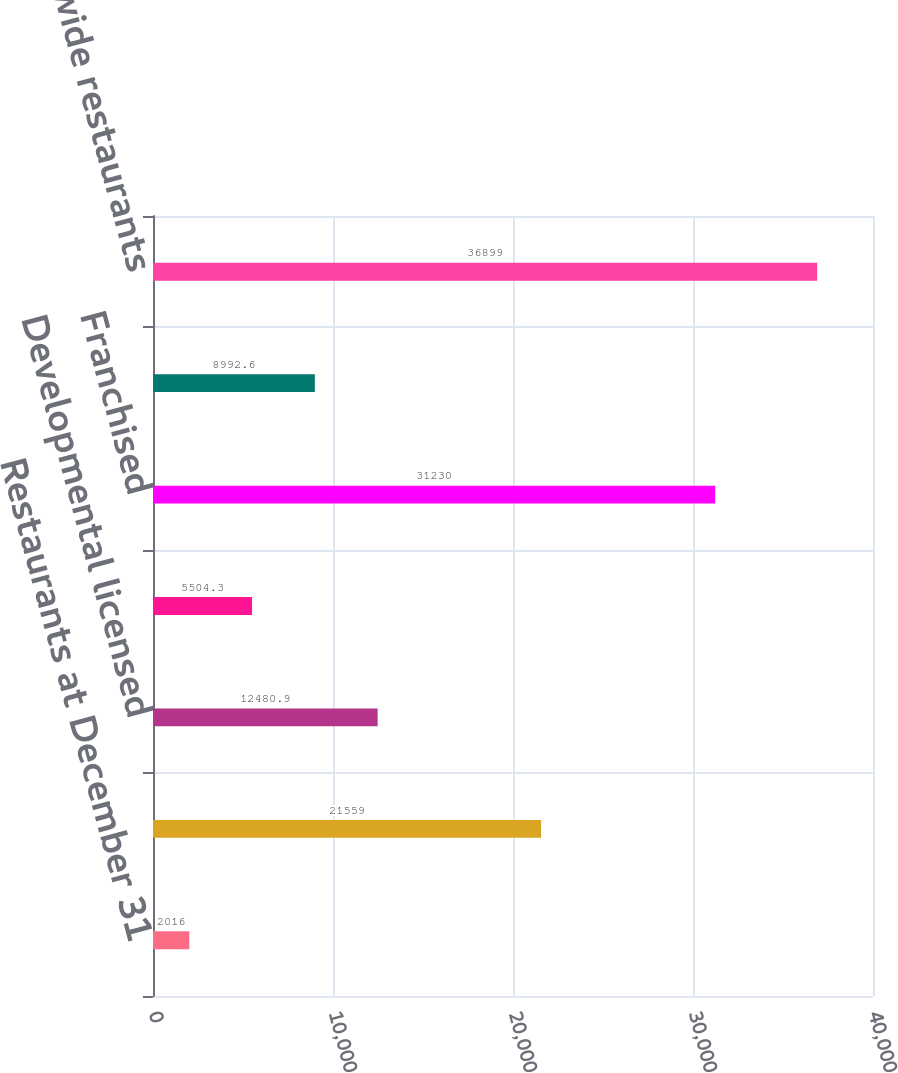<chart> <loc_0><loc_0><loc_500><loc_500><bar_chart><fcel>Restaurants at December 31<fcel>Conventional franchised<fcel>Developmental licensed<fcel>Foreign affiliated<fcel>Franchised<fcel>Company-operated<fcel>Systemwide restaurants<nl><fcel>2016<fcel>21559<fcel>12480.9<fcel>5504.3<fcel>31230<fcel>8992.6<fcel>36899<nl></chart> 